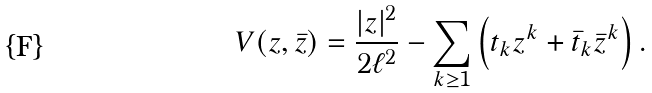Convert formula to latex. <formula><loc_0><loc_0><loc_500><loc_500>V ( z , \bar { z } ) = \frac { | z | ^ { 2 } } { 2 \ell ^ { 2 } } - \sum _ { k \geq 1 } \left ( t _ { k } z ^ { k } + \bar { t } _ { k } \bar { z } ^ { k } \right ) .</formula> 